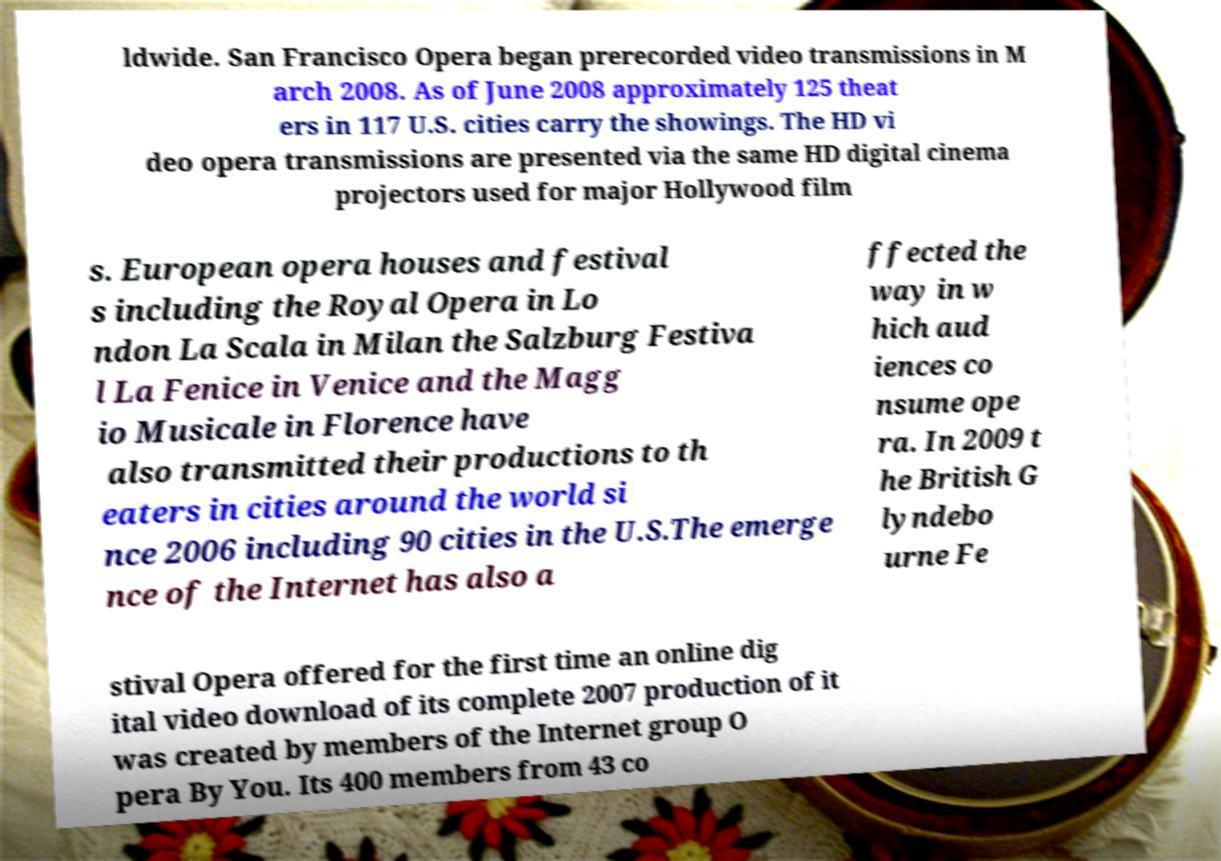Please read and relay the text visible in this image. What does it say? ldwide. San Francisco Opera began prerecorded video transmissions in M arch 2008. As of June 2008 approximately 125 theat ers in 117 U.S. cities carry the showings. The HD vi deo opera transmissions are presented via the same HD digital cinema projectors used for major Hollywood film s. European opera houses and festival s including the Royal Opera in Lo ndon La Scala in Milan the Salzburg Festiva l La Fenice in Venice and the Magg io Musicale in Florence have also transmitted their productions to th eaters in cities around the world si nce 2006 including 90 cities in the U.S.The emerge nce of the Internet has also a ffected the way in w hich aud iences co nsume ope ra. In 2009 t he British G lyndebo urne Fe stival Opera offered for the first time an online dig ital video download of its complete 2007 production of it was created by members of the Internet group O pera By You. Its 400 members from 43 co 